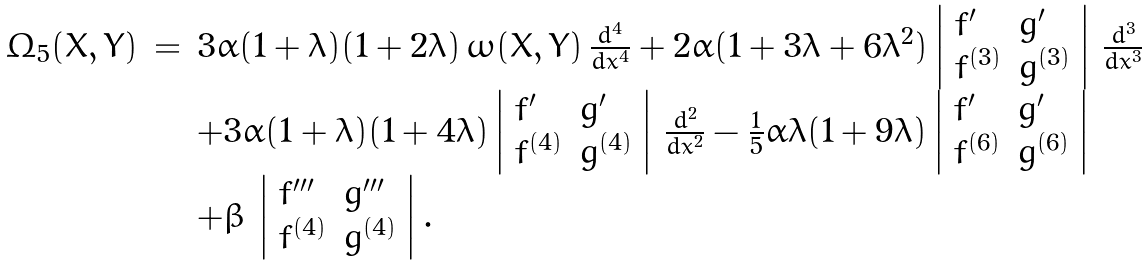Convert formula to latex. <formula><loc_0><loc_0><loc_500><loc_500>\begin{array} { l c l } \Omega _ { 5 } ( X , Y ) & = & 3 \alpha ( 1 + \lambda ) ( 1 + 2 \lambda ) \, \omega ( X , Y ) \, \frac { d ^ { 4 } } { d x ^ { 4 } } + 2 \alpha ( 1 + 3 \lambda + 6 \lambda ^ { 2 } ) \left | \begin{array} { l l } f ^ { \prime } & g ^ { \prime } \\ f ^ { ( 3 ) } & g ^ { ( 3 ) } \end{array} \right | \, \frac { d ^ { 3 } } { d x ^ { 3 } } \\ & & + 3 \alpha ( 1 + \lambda ) ( 1 + 4 \lambda ) \left | \begin{array} { l l } f ^ { \prime } & g ^ { \prime } \\ f ^ { ( 4 ) } & g ^ { ( 4 ) } \end{array} \right | \, \frac { d ^ { 2 } } { d x ^ { 2 } } - \frac { 1 } { 5 } \alpha \lambda ( 1 + 9 \lambda ) \left | \begin{array} { l l } f ^ { \prime } & g ^ { \prime } \\ f ^ { ( 6 ) } & g ^ { ( 6 ) } \end{array} \right | \\ & & + \beta \, \left | \begin{array} { l l } f ^ { \prime \prime \prime } & g ^ { \prime \prime \prime } \\ f ^ { ( 4 ) } & g ^ { ( 4 ) } \end{array} \right | . \end{array}</formula> 